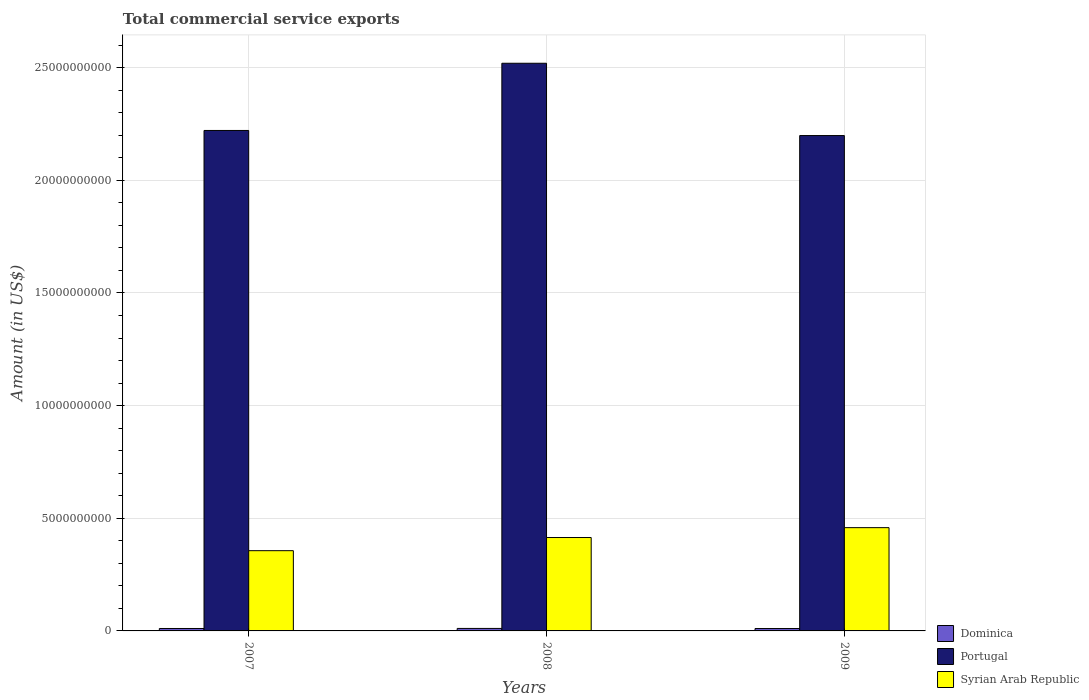How many different coloured bars are there?
Your answer should be compact. 3. How many groups of bars are there?
Keep it short and to the point. 3. Are the number of bars per tick equal to the number of legend labels?
Keep it short and to the point. Yes. How many bars are there on the 1st tick from the left?
Offer a very short reply. 3. How many bars are there on the 3rd tick from the right?
Give a very brief answer. 3. What is the label of the 3rd group of bars from the left?
Give a very brief answer. 2009. What is the total commercial service exports in Dominica in 2008?
Provide a succinct answer. 1.11e+08. Across all years, what is the maximum total commercial service exports in Syrian Arab Republic?
Provide a short and direct response. 4.58e+09. Across all years, what is the minimum total commercial service exports in Dominica?
Offer a terse response. 1.06e+08. In which year was the total commercial service exports in Syrian Arab Republic maximum?
Keep it short and to the point. 2009. What is the total total commercial service exports in Syrian Arab Republic in the graph?
Keep it short and to the point. 1.23e+1. What is the difference between the total commercial service exports in Dominica in 2007 and that in 2008?
Offer a very short reply. -3.38e+06. What is the difference between the total commercial service exports in Portugal in 2007 and the total commercial service exports in Dominica in 2008?
Provide a short and direct response. 2.21e+1. What is the average total commercial service exports in Syrian Arab Republic per year?
Make the answer very short. 4.10e+09. In the year 2009, what is the difference between the total commercial service exports in Dominica and total commercial service exports in Syrian Arab Republic?
Provide a short and direct response. -4.48e+09. In how many years, is the total commercial service exports in Dominica greater than 11000000000 US$?
Offer a terse response. 0. What is the ratio of the total commercial service exports in Portugal in 2007 to that in 2009?
Give a very brief answer. 1.01. Is the total commercial service exports in Portugal in 2007 less than that in 2008?
Offer a very short reply. Yes. Is the difference between the total commercial service exports in Dominica in 2007 and 2008 greater than the difference between the total commercial service exports in Syrian Arab Republic in 2007 and 2008?
Offer a very short reply. Yes. What is the difference between the highest and the second highest total commercial service exports in Dominica?
Provide a short and direct response. 3.38e+06. What is the difference between the highest and the lowest total commercial service exports in Dominica?
Offer a very short reply. 4.71e+06. What does the 2nd bar from the left in 2007 represents?
Offer a terse response. Portugal. What does the 2nd bar from the right in 2007 represents?
Offer a very short reply. Portugal. How many bars are there?
Provide a short and direct response. 9. How many years are there in the graph?
Give a very brief answer. 3. Does the graph contain grids?
Ensure brevity in your answer.  Yes. How many legend labels are there?
Provide a short and direct response. 3. How are the legend labels stacked?
Your response must be concise. Vertical. What is the title of the graph?
Provide a short and direct response. Total commercial service exports. What is the label or title of the Y-axis?
Your answer should be compact. Amount (in US$). What is the Amount (in US$) of Dominica in 2007?
Your response must be concise. 1.08e+08. What is the Amount (in US$) of Portugal in 2007?
Provide a succinct answer. 2.22e+1. What is the Amount (in US$) in Syrian Arab Republic in 2007?
Give a very brief answer. 3.56e+09. What is the Amount (in US$) in Dominica in 2008?
Ensure brevity in your answer.  1.11e+08. What is the Amount (in US$) in Portugal in 2008?
Offer a terse response. 2.52e+1. What is the Amount (in US$) in Syrian Arab Republic in 2008?
Keep it short and to the point. 4.15e+09. What is the Amount (in US$) in Dominica in 2009?
Offer a terse response. 1.06e+08. What is the Amount (in US$) of Portugal in 2009?
Make the answer very short. 2.20e+1. What is the Amount (in US$) in Syrian Arab Republic in 2009?
Provide a succinct answer. 4.58e+09. Across all years, what is the maximum Amount (in US$) of Dominica?
Provide a succinct answer. 1.11e+08. Across all years, what is the maximum Amount (in US$) in Portugal?
Provide a succinct answer. 2.52e+1. Across all years, what is the maximum Amount (in US$) in Syrian Arab Republic?
Your answer should be very brief. 4.58e+09. Across all years, what is the minimum Amount (in US$) of Dominica?
Provide a short and direct response. 1.06e+08. Across all years, what is the minimum Amount (in US$) in Portugal?
Offer a very short reply. 2.20e+1. Across all years, what is the minimum Amount (in US$) in Syrian Arab Republic?
Make the answer very short. 3.56e+09. What is the total Amount (in US$) in Dominica in the graph?
Offer a terse response. 3.25e+08. What is the total Amount (in US$) in Portugal in the graph?
Keep it short and to the point. 6.94e+1. What is the total Amount (in US$) of Syrian Arab Republic in the graph?
Ensure brevity in your answer.  1.23e+1. What is the difference between the Amount (in US$) of Dominica in 2007 and that in 2008?
Your response must be concise. -3.38e+06. What is the difference between the Amount (in US$) of Portugal in 2007 and that in 2008?
Provide a succinct answer. -2.98e+09. What is the difference between the Amount (in US$) of Syrian Arab Republic in 2007 and that in 2008?
Provide a succinct answer. -5.84e+08. What is the difference between the Amount (in US$) in Dominica in 2007 and that in 2009?
Offer a very short reply. 1.33e+06. What is the difference between the Amount (in US$) in Portugal in 2007 and that in 2009?
Provide a short and direct response. 2.26e+08. What is the difference between the Amount (in US$) in Syrian Arab Republic in 2007 and that in 2009?
Your answer should be compact. -1.02e+09. What is the difference between the Amount (in US$) in Dominica in 2008 and that in 2009?
Your answer should be very brief. 4.71e+06. What is the difference between the Amount (in US$) in Portugal in 2008 and that in 2009?
Offer a very short reply. 3.21e+09. What is the difference between the Amount (in US$) of Syrian Arab Republic in 2008 and that in 2009?
Provide a succinct answer. -4.38e+08. What is the difference between the Amount (in US$) in Dominica in 2007 and the Amount (in US$) in Portugal in 2008?
Make the answer very short. -2.51e+1. What is the difference between the Amount (in US$) in Dominica in 2007 and the Amount (in US$) in Syrian Arab Republic in 2008?
Make the answer very short. -4.04e+09. What is the difference between the Amount (in US$) of Portugal in 2007 and the Amount (in US$) of Syrian Arab Republic in 2008?
Your response must be concise. 1.81e+1. What is the difference between the Amount (in US$) in Dominica in 2007 and the Amount (in US$) in Portugal in 2009?
Offer a terse response. -2.19e+1. What is the difference between the Amount (in US$) in Dominica in 2007 and the Amount (in US$) in Syrian Arab Republic in 2009?
Offer a very short reply. -4.48e+09. What is the difference between the Amount (in US$) in Portugal in 2007 and the Amount (in US$) in Syrian Arab Republic in 2009?
Ensure brevity in your answer.  1.76e+1. What is the difference between the Amount (in US$) in Dominica in 2008 and the Amount (in US$) in Portugal in 2009?
Make the answer very short. -2.19e+1. What is the difference between the Amount (in US$) of Dominica in 2008 and the Amount (in US$) of Syrian Arab Republic in 2009?
Make the answer very short. -4.47e+09. What is the difference between the Amount (in US$) in Portugal in 2008 and the Amount (in US$) in Syrian Arab Republic in 2009?
Provide a short and direct response. 2.06e+1. What is the average Amount (in US$) in Dominica per year?
Give a very brief answer. 1.08e+08. What is the average Amount (in US$) in Portugal per year?
Offer a very short reply. 2.31e+1. What is the average Amount (in US$) in Syrian Arab Republic per year?
Your answer should be very brief. 4.10e+09. In the year 2007, what is the difference between the Amount (in US$) of Dominica and Amount (in US$) of Portugal?
Provide a succinct answer. -2.21e+1. In the year 2007, what is the difference between the Amount (in US$) of Dominica and Amount (in US$) of Syrian Arab Republic?
Provide a succinct answer. -3.45e+09. In the year 2007, what is the difference between the Amount (in US$) of Portugal and Amount (in US$) of Syrian Arab Republic?
Your response must be concise. 1.87e+1. In the year 2008, what is the difference between the Amount (in US$) of Dominica and Amount (in US$) of Portugal?
Your response must be concise. -2.51e+1. In the year 2008, what is the difference between the Amount (in US$) in Dominica and Amount (in US$) in Syrian Arab Republic?
Your response must be concise. -4.03e+09. In the year 2008, what is the difference between the Amount (in US$) of Portugal and Amount (in US$) of Syrian Arab Republic?
Ensure brevity in your answer.  2.10e+1. In the year 2009, what is the difference between the Amount (in US$) in Dominica and Amount (in US$) in Portugal?
Give a very brief answer. -2.19e+1. In the year 2009, what is the difference between the Amount (in US$) in Dominica and Amount (in US$) in Syrian Arab Republic?
Offer a very short reply. -4.48e+09. In the year 2009, what is the difference between the Amount (in US$) of Portugal and Amount (in US$) of Syrian Arab Republic?
Provide a short and direct response. 1.74e+1. What is the ratio of the Amount (in US$) in Dominica in 2007 to that in 2008?
Offer a terse response. 0.97. What is the ratio of the Amount (in US$) of Portugal in 2007 to that in 2008?
Offer a very short reply. 0.88. What is the ratio of the Amount (in US$) in Syrian Arab Republic in 2007 to that in 2008?
Give a very brief answer. 0.86. What is the ratio of the Amount (in US$) in Dominica in 2007 to that in 2009?
Make the answer very short. 1.01. What is the ratio of the Amount (in US$) of Portugal in 2007 to that in 2009?
Make the answer very short. 1.01. What is the ratio of the Amount (in US$) in Syrian Arab Republic in 2007 to that in 2009?
Keep it short and to the point. 0.78. What is the ratio of the Amount (in US$) of Dominica in 2008 to that in 2009?
Make the answer very short. 1.04. What is the ratio of the Amount (in US$) of Portugal in 2008 to that in 2009?
Make the answer very short. 1.15. What is the ratio of the Amount (in US$) of Syrian Arab Republic in 2008 to that in 2009?
Make the answer very short. 0.9. What is the difference between the highest and the second highest Amount (in US$) of Dominica?
Your answer should be very brief. 3.38e+06. What is the difference between the highest and the second highest Amount (in US$) in Portugal?
Ensure brevity in your answer.  2.98e+09. What is the difference between the highest and the second highest Amount (in US$) in Syrian Arab Republic?
Your answer should be compact. 4.38e+08. What is the difference between the highest and the lowest Amount (in US$) of Dominica?
Provide a short and direct response. 4.71e+06. What is the difference between the highest and the lowest Amount (in US$) in Portugal?
Your answer should be very brief. 3.21e+09. What is the difference between the highest and the lowest Amount (in US$) of Syrian Arab Republic?
Keep it short and to the point. 1.02e+09. 